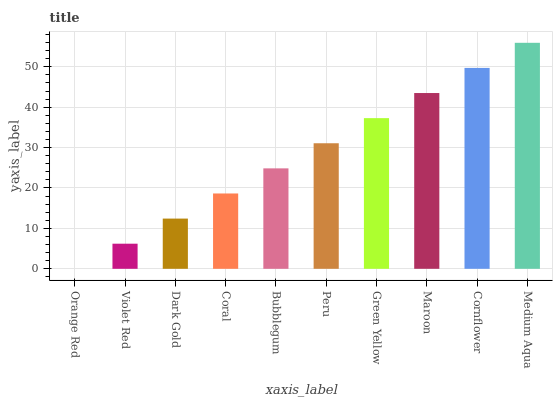Is Orange Red the minimum?
Answer yes or no. Yes. Is Medium Aqua the maximum?
Answer yes or no. Yes. Is Violet Red the minimum?
Answer yes or no. No. Is Violet Red the maximum?
Answer yes or no. No. Is Violet Red greater than Orange Red?
Answer yes or no. Yes. Is Orange Red less than Violet Red?
Answer yes or no. Yes. Is Orange Red greater than Violet Red?
Answer yes or no. No. Is Violet Red less than Orange Red?
Answer yes or no. No. Is Peru the high median?
Answer yes or no. Yes. Is Bubblegum the low median?
Answer yes or no. Yes. Is Bubblegum the high median?
Answer yes or no. No. Is Orange Red the low median?
Answer yes or no. No. 